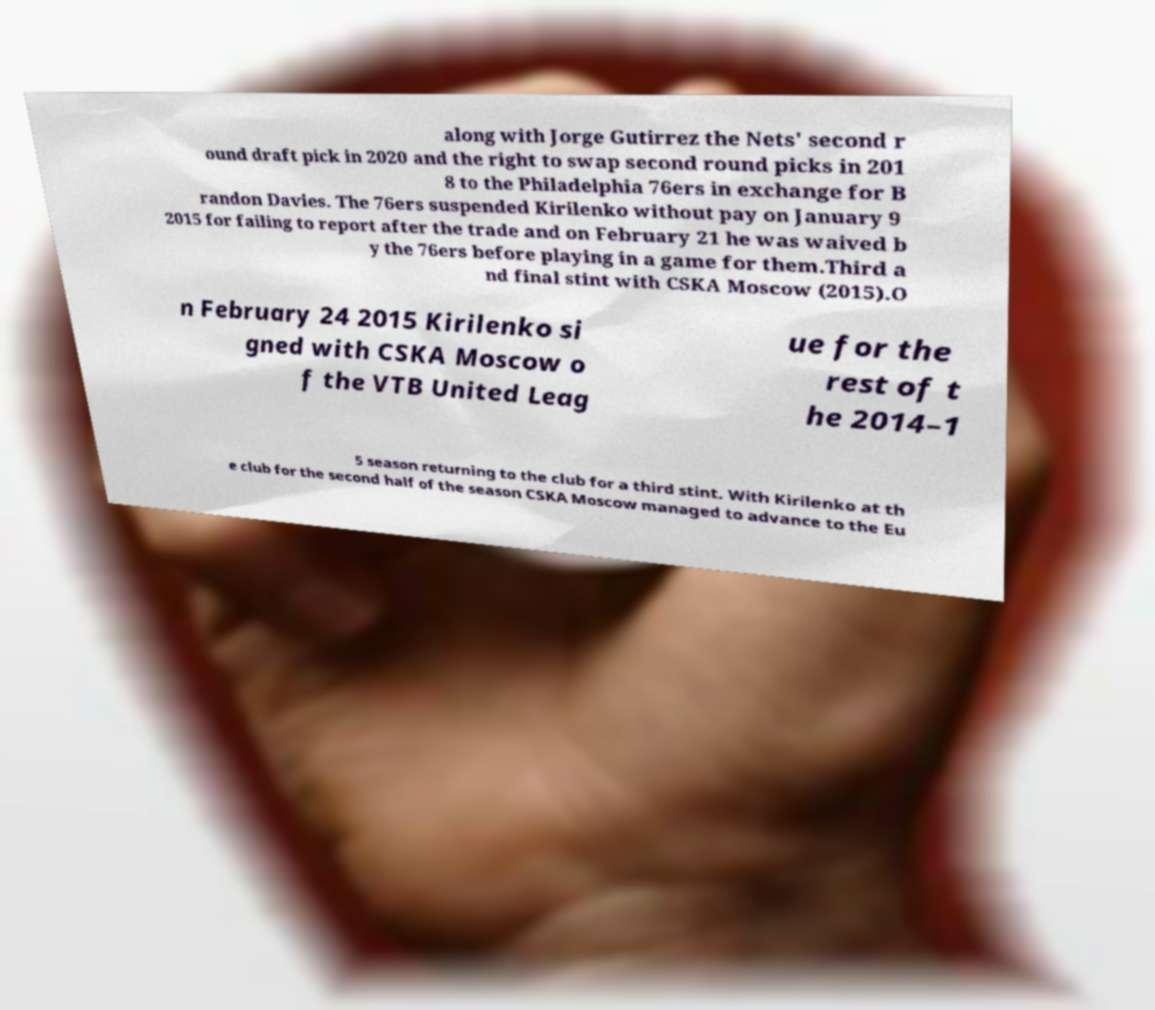What messages or text are displayed in this image? I need them in a readable, typed format. along with Jorge Gutirrez the Nets' second r ound draft pick in 2020 and the right to swap second round picks in 201 8 to the Philadelphia 76ers in exchange for B randon Davies. The 76ers suspended Kirilenko without pay on January 9 2015 for failing to report after the trade and on February 21 he was waived b y the 76ers before playing in a game for them.Third a nd final stint with CSKA Moscow (2015).O n February 24 2015 Kirilenko si gned with CSKA Moscow o f the VTB United Leag ue for the rest of t he 2014–1 5 season returning to the club for a third stint. With Kirilenko at th e club for the second half of the season CSKA Moscow managed to advance to the Eu 